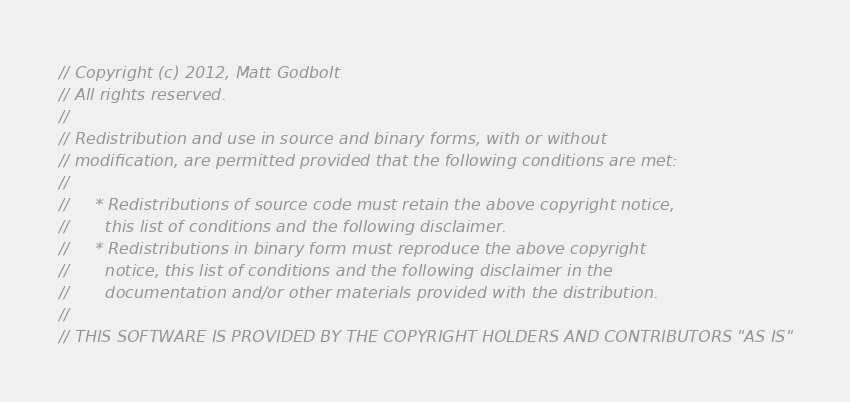<code> <loc_0><loc_0><loc_500><loc_500><_JavaScript_>// Copyright (c) 2012, Matt Godbolt
// All rights reserved.
//
// Redistribution and use in source and binary forms, with or without
// modification, are permitted provided that the following conditions are met:
//
//     * Redistributions of source code must retain the above copyright notice,
//       this list of conditions and the following disclaimer.
//     * Redistributions in binary form must reproduce the above copyright
//       notice, this list of conditions and the following disclaimer in the
//       documentation and/or other materials provided with the distribution.
//
// THIS SOFTWARE IS PROVIDED BY THE COPYRIGHT HOLDERS AND CONTRIBUTORS "AS IS"</code> 